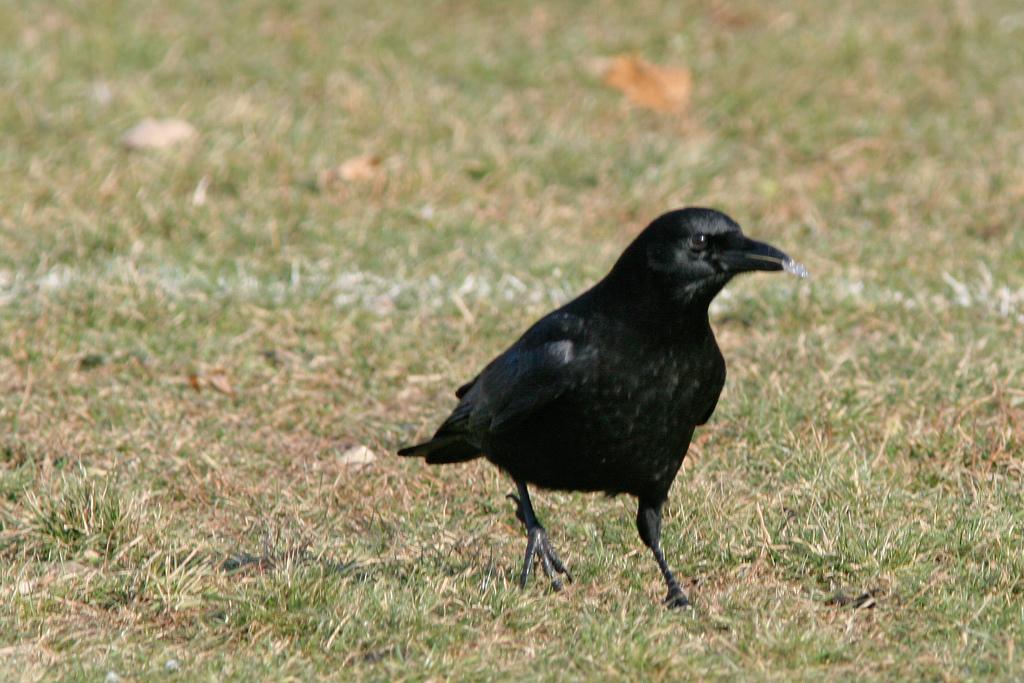Please provide a concise description of this image. In this image we can see one crow on the ground with some food in the crow mouth, some green grass on the ground and some objects on the ground. 